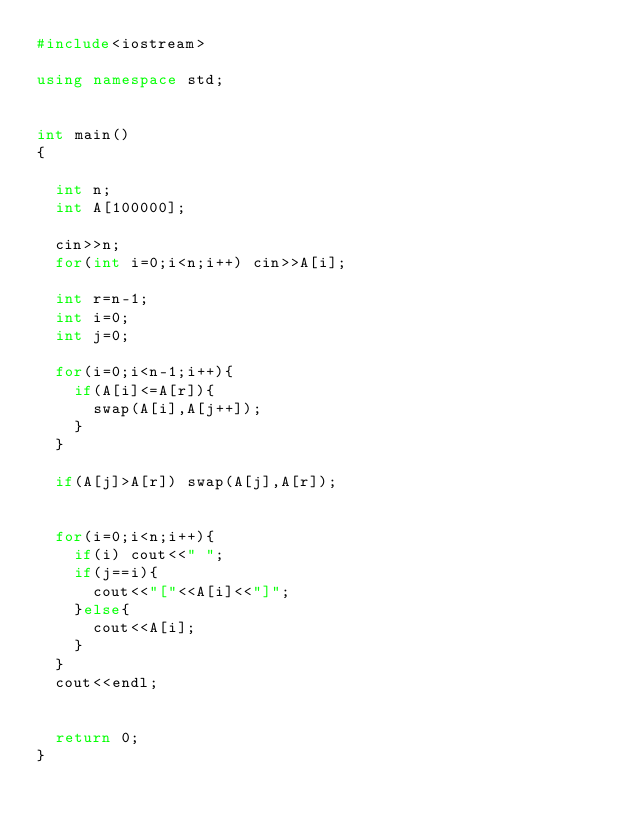<code> <loc_0><loc_0><loc_500><loc_500><_C++_>#include<iostream>

using namespace std;


int main()
{

	int n;
	int A[100000];

	cin>>n;
	for(int i=0;i<n;i++) cin>>A[i];

	int r=n-1;
	int i=0;
	int j=0;

	for(i=0;i<n-1;i++){
		if(A[i]<=A[r]){
			swap(A[i],A[j++]);
		}
	}

	if(A[j]>A[r]) swap(A[j],A[r]);

	
	for(i=0;i<n;i++){
		if(i) cout<<" ";
		if(j==i){
			cout<<"["<<A[i]<<"]";
		}else{
			cout<<A[i];
		}
	}
	cout<<endl;


	return 0;
}

</code> 